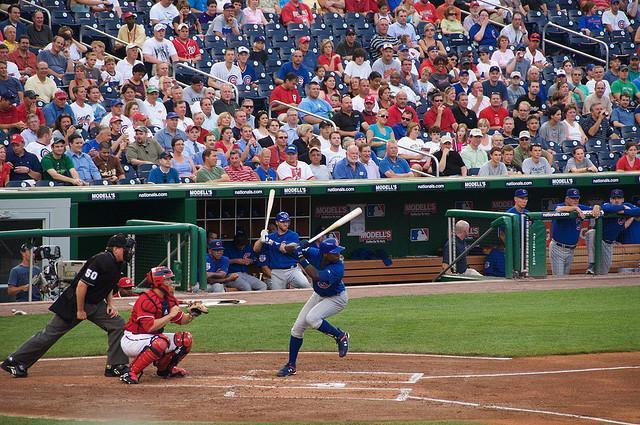How many people can be seen?
Give a very brief answer. 6. How many toothbrushes can you spot?
Give a very brief answer. 0. 